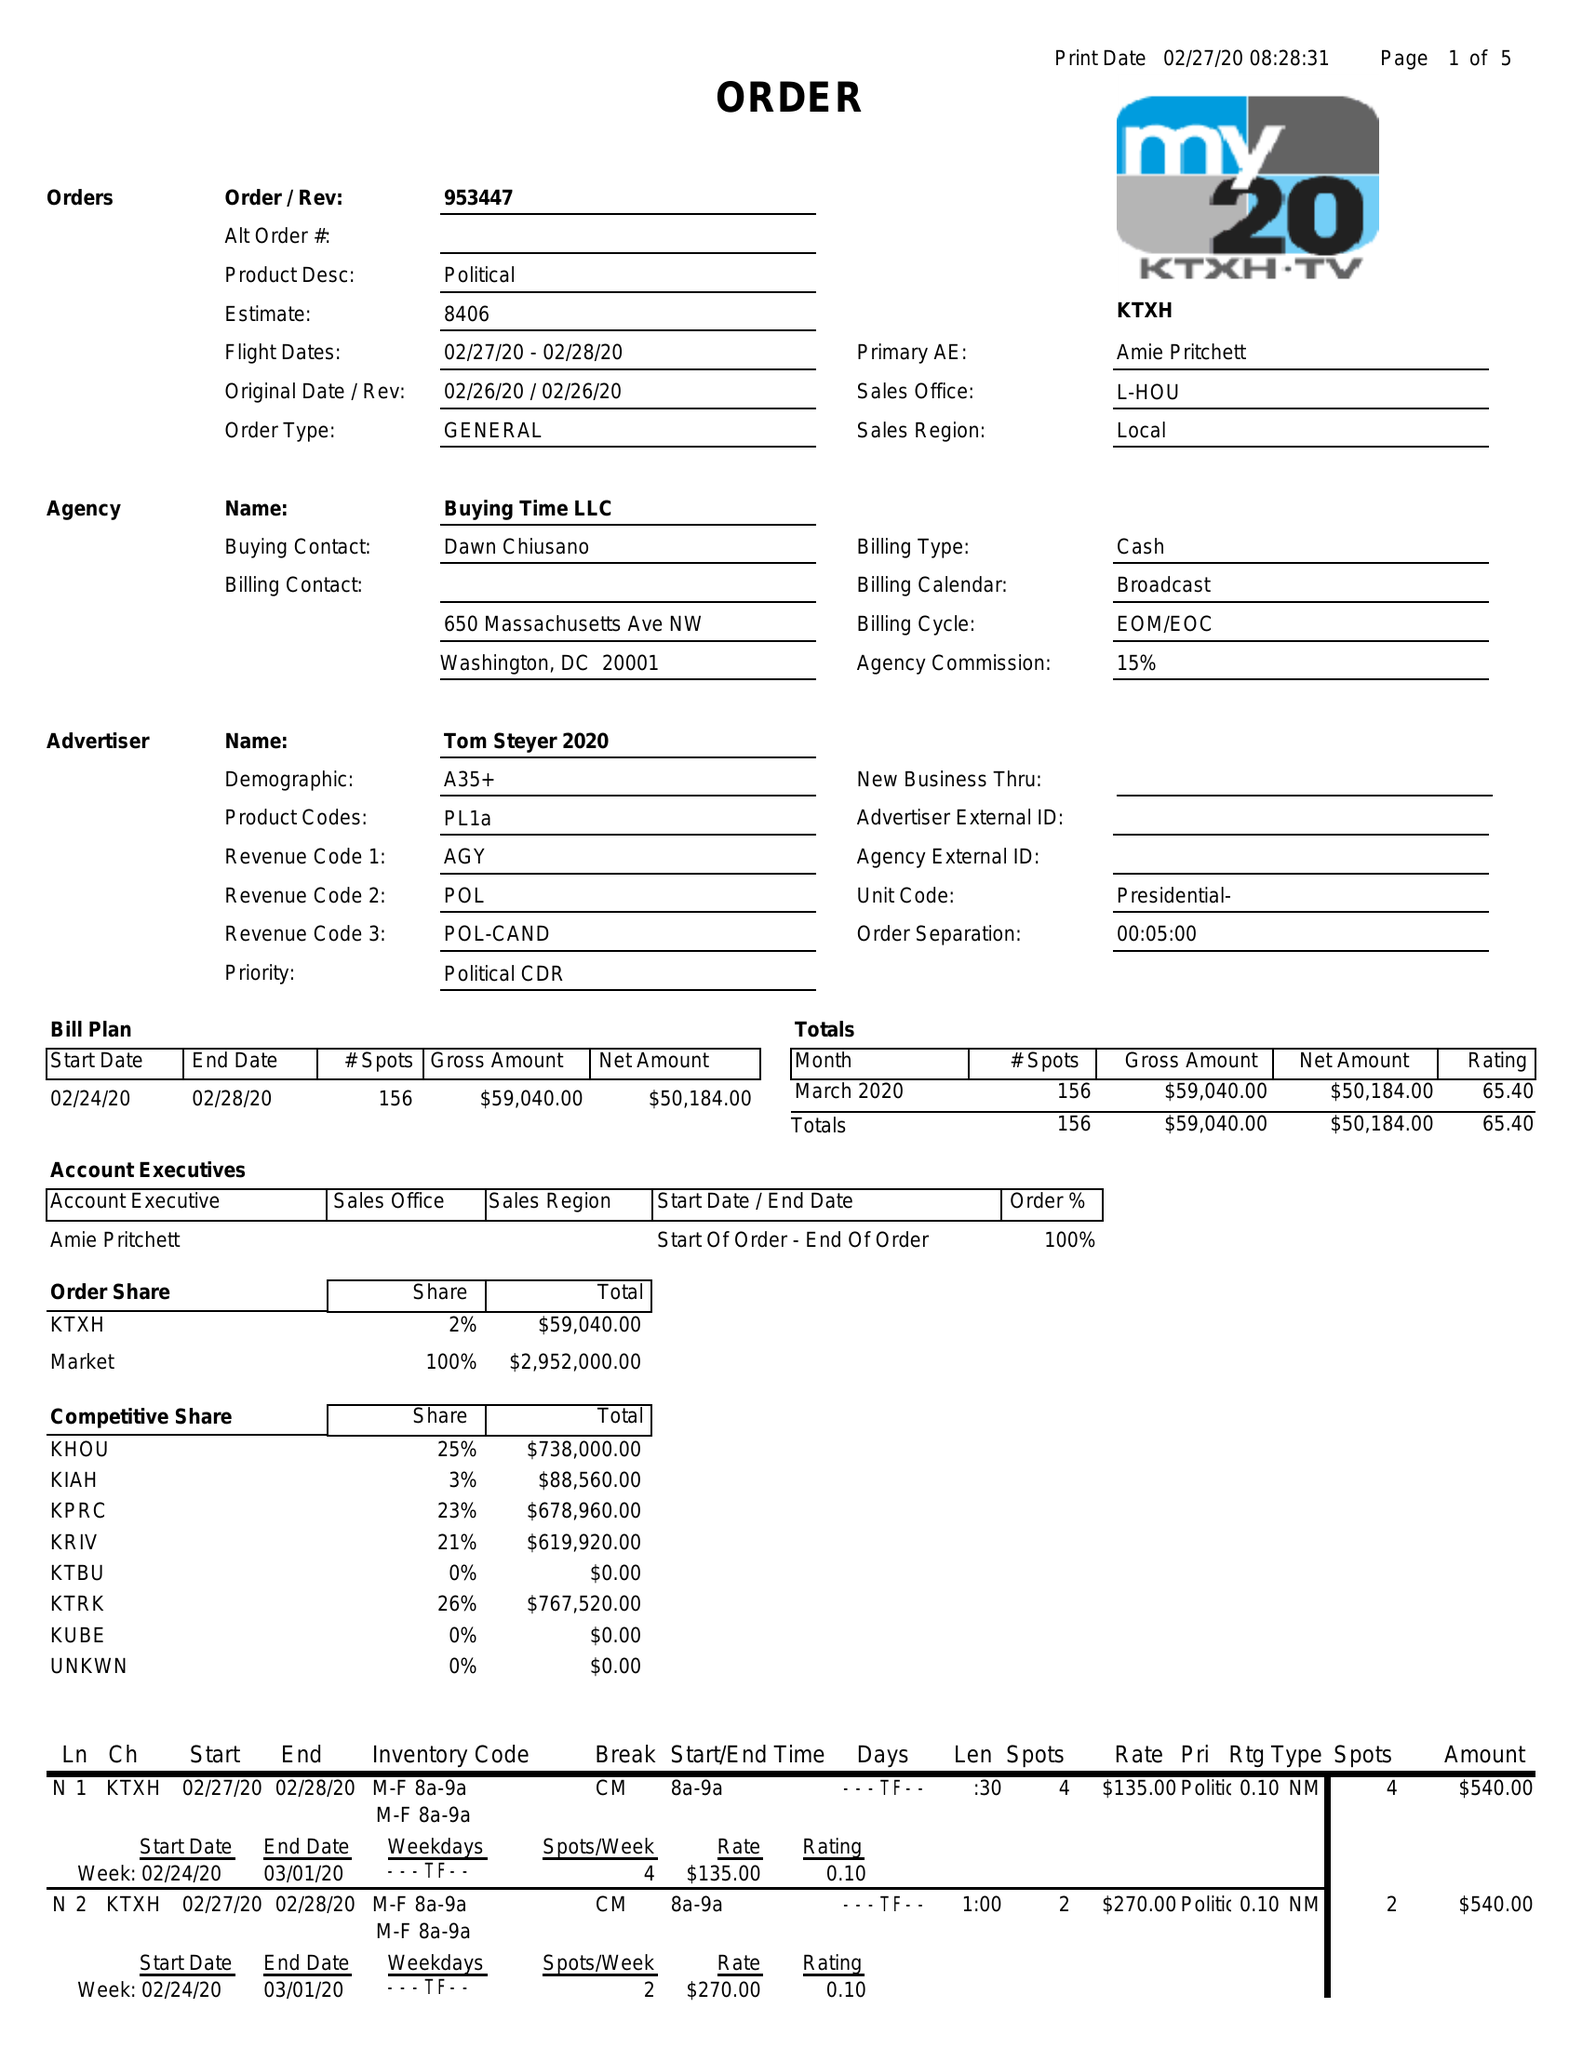What is the value for the contract_num?
Answer the question using a single word or phrase. 953447 